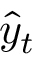Convert formula to latex. <formula><loc_0><loc_0><loc_500><loc_500>\hat { y } _ { t }</formula> 